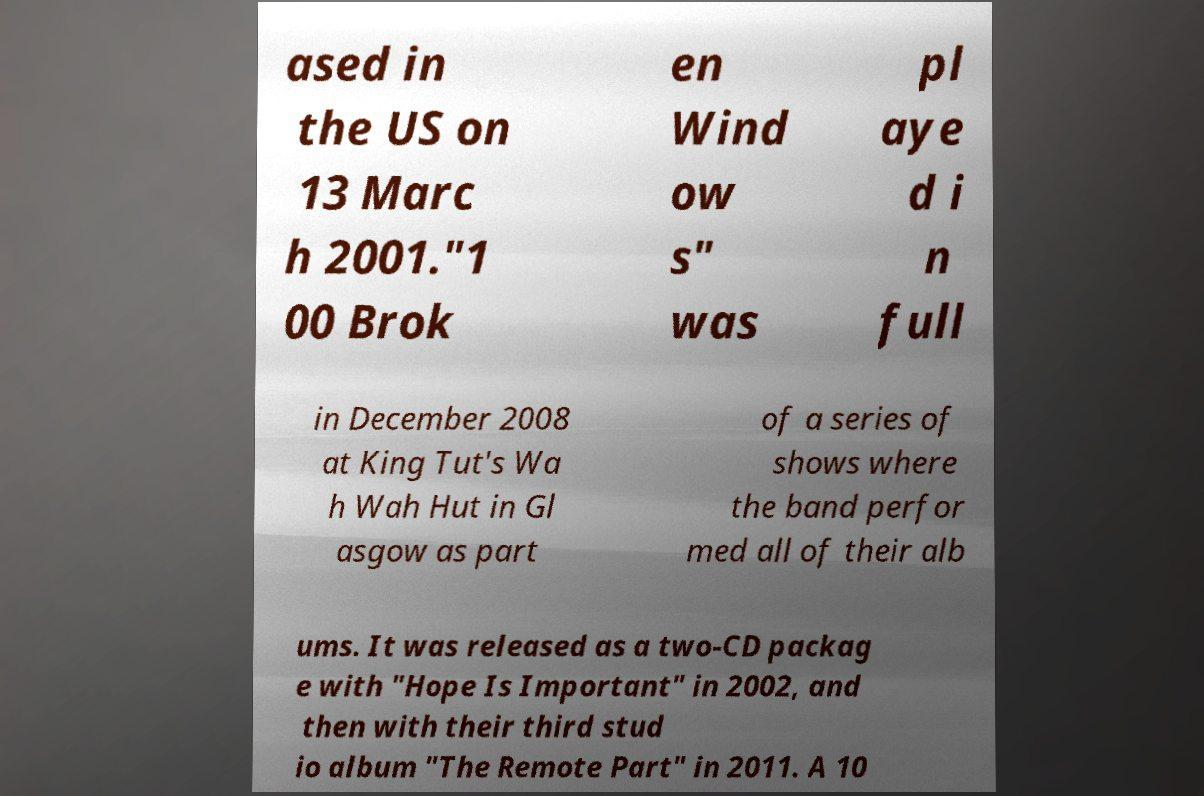For documentation purposes, I need the text within this image transcribed. Could you provide that? ased in the US on 13 Marc h 2001."1 00 Brok en Wind ow s" was pl aye d i n full in December 2008 at King Tut's Wa h Wah Hut in Gl asgow as part of a series of shows where the band perfor med all of their alb ums. It was released as a two-CD packag e with "Hope Is Important" in 2002, and then with their third stud io album "The Remote Part" in 2011. A 10 